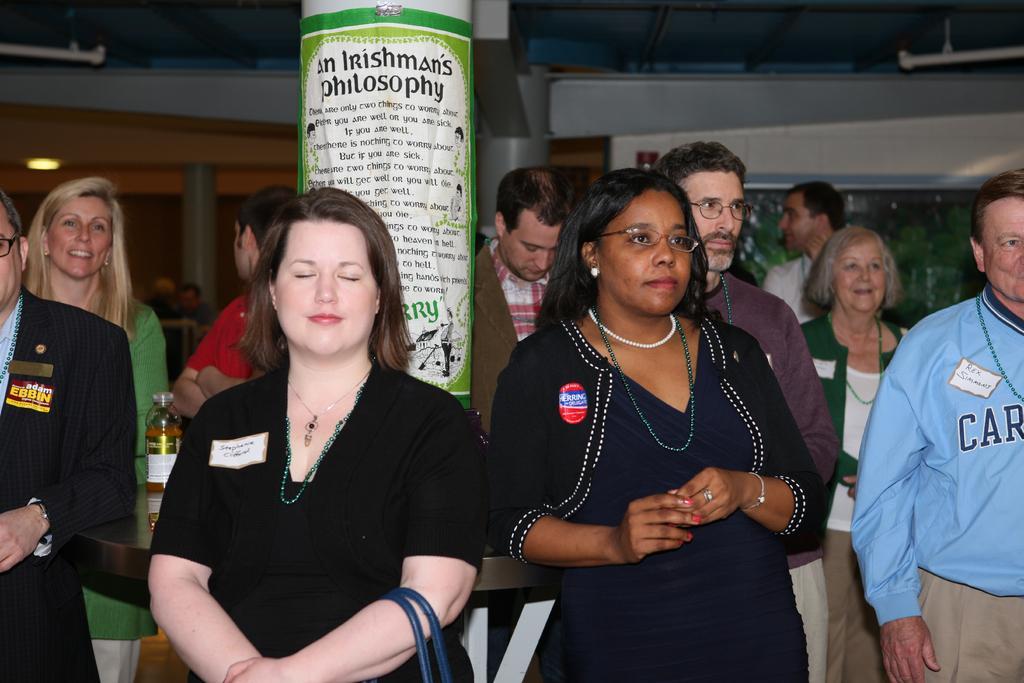Could you give a brief overview of what you see in this image? In this picture there is a woman who is wearing black dress, beside her there is another woman who is wearing spectacles and black dress. On the right there is a man who is standing near to them. Beside the pillars we can see many peoples were standing. Behind this woman there is a table. On the table i can see one bottle. In the back i can see the window. In the top right corner there is a tube light which is hanging from the roof. 